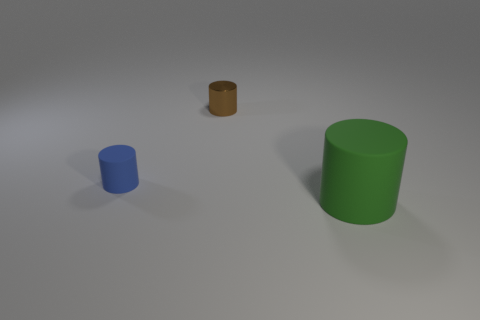Is there any other thing that has the same material as the brown object? There appears to be a consistency in the objects' materials, suggesting that the blue and green objects might be made of the same or similar material as the brown one, such as plastic or a digitally rendered equivalent. 